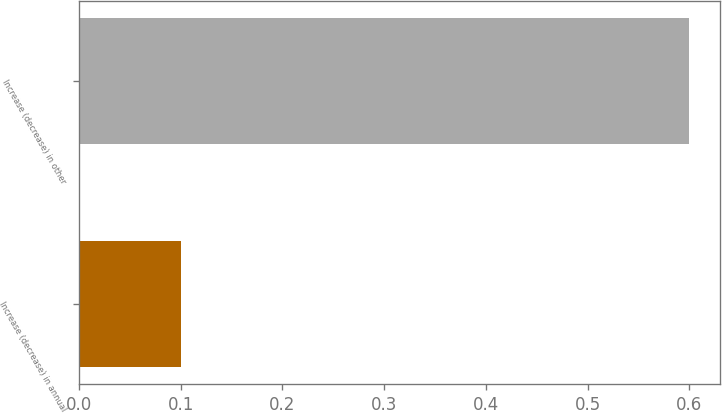Convert chart. <chart><loc_0><loc_0><loc_500><loc_500><bar_chart><fcel>Increase (decrease) in annual<fcel>Increase (decrease) in other<nl><fcel>0.1<fcel>0.6<nl></chart> 